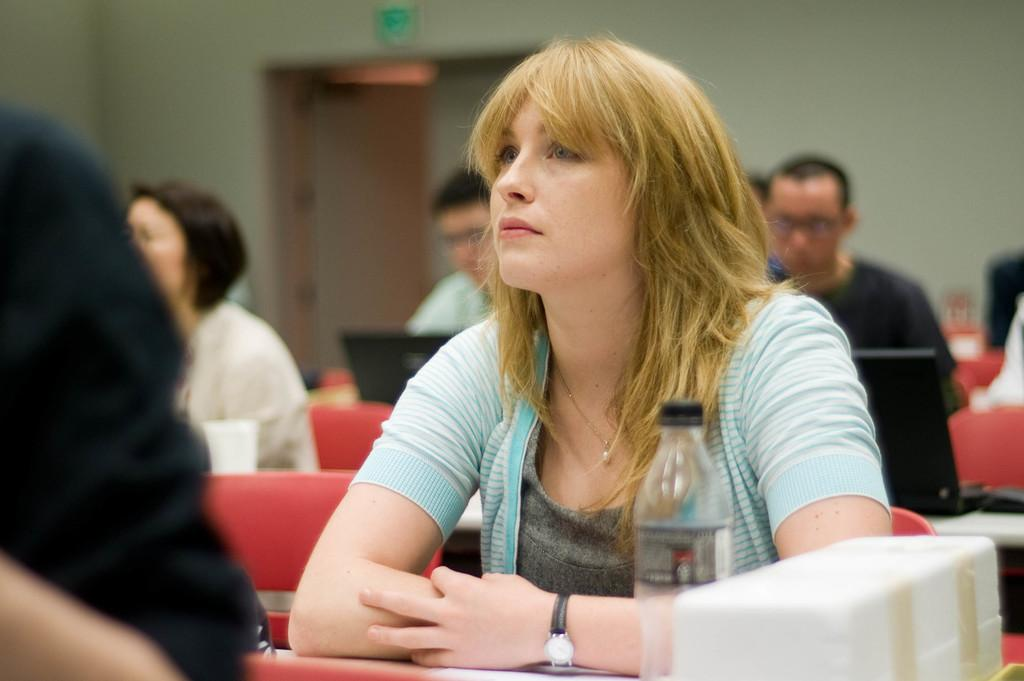What are the persons in the image doing? The persons in the image are sitting on chairs. What furniture is present in the image besides the chairs? There are tables in the image. What type of objects can be seen on the tables? There is a bottle, a cup, and a box on the tables. What electronic devices are visible in the image? There are laptops in the image. What can be seen in the background of the image? There is a wall, a board, and a door in the background. Can you see an apple being shared between the persons in the image? There is no apple present in the image. What type of loss is depicted in the image? There is no loss depicted in the image; it features persons sitting on chairs, tables, laptops, and background elements. 